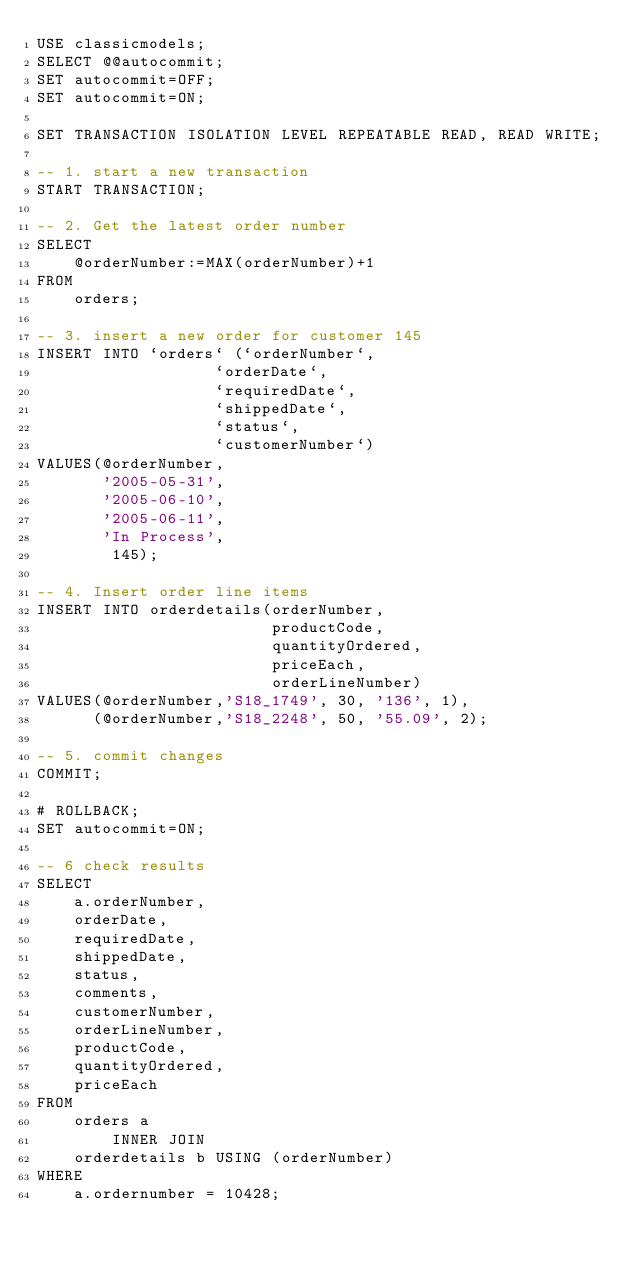<code> <loc_0><loc_0><loc_500><loc_500><_SQL_>USE classicmodels;
SELECT @@autocommit;
SET autocommit=OFF;
SET autocommit=ON;

SET TRANSACTION ISOLATION LEVEL REPEATABLE READ, READ WRITE;

-- 1. start a new transaction
START TRANSACTION;

-- 2. Get the latest order number
SELECT 
    @orderNumber:=MAX(orderNumber)+1
FROM
    orders;

-- 3. insert a new order for customer 145
INSERT INTO `orders` (`orderNumber`,
                   `orderDate`,
                   `requiredDate`,
                   `shippedDate`,
                   `status`,
                   `customerNumber`)
VALUES(@orderNumber,
       '2005-05-31',
       '2005-06-10',
       '2005-06-11',
       'In Process',
        145);
   
-- 4. Insert order line items
INSERT INTO orderdetails(orderNumber,
                         productCode,
                         quantityOrdered,
                         priceEach,
                         orderLineNumber)
VALUES(@orderNumber,'S18_1749', 30, '136', 1),
      (@orderNumber,'S18_2248', 50, '55.09', 2);    
   
-- 5. commit changes    
COMMIT;   
   
# ROLLBACK;
SET autocommit=ON;

-- 6 check results
SELECT 
    a.orderNumber,
    orderDate,
    requiredDate,
    shippedDate,
    status,
    comments,
    customerNumber,
    orderLineNumber,
    productCode,
    quantityOrdered,
    priceEach
FROM
    orders a
        INNER JOIN
    orderdetails b USING (orderNumber)
WHERE
    a.ordernumber = 10428;	</code> 